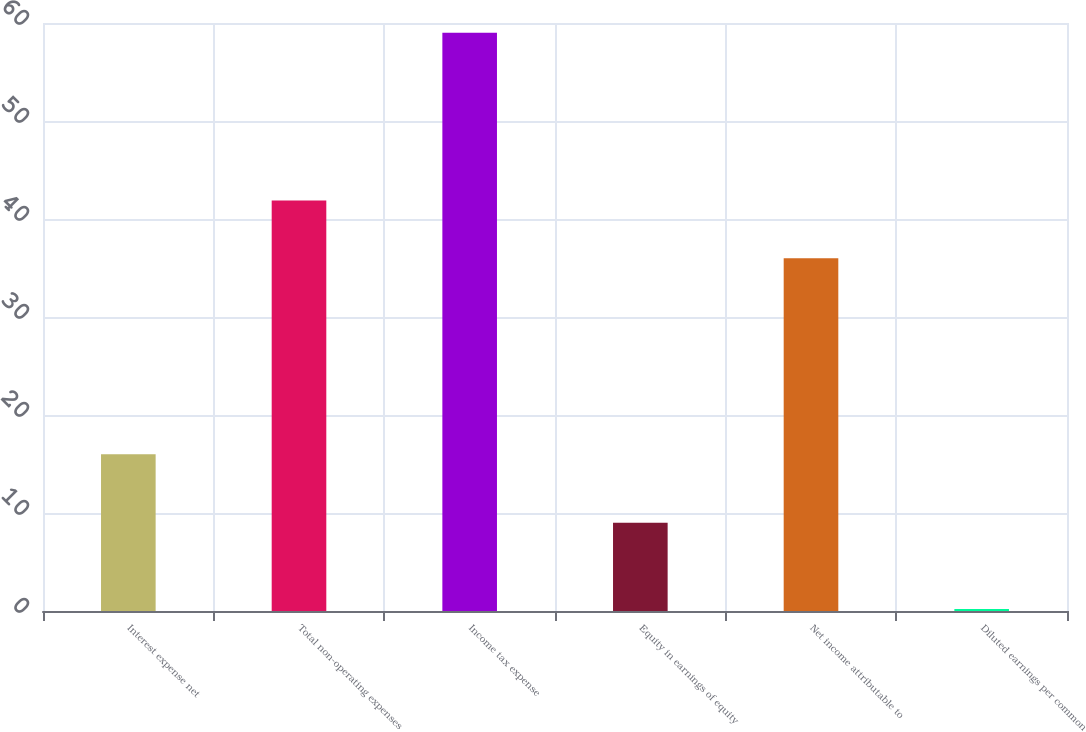Convert chart to OTSL. <chart><loc_0><loc_0><loc_500><loc_500><bar_chart><fcel>Interest expense net<fcel>Total non-operating expenses<fcel>Income tax expense<fcel>Equity in earnings of equity<fcel>Net income attributable to<fcel>Diluted earnings per common<nl><fcel>16<fcel>41.88<fcel>59<fcel>9<fcel>36<fcel>0.21<nl></chart> 